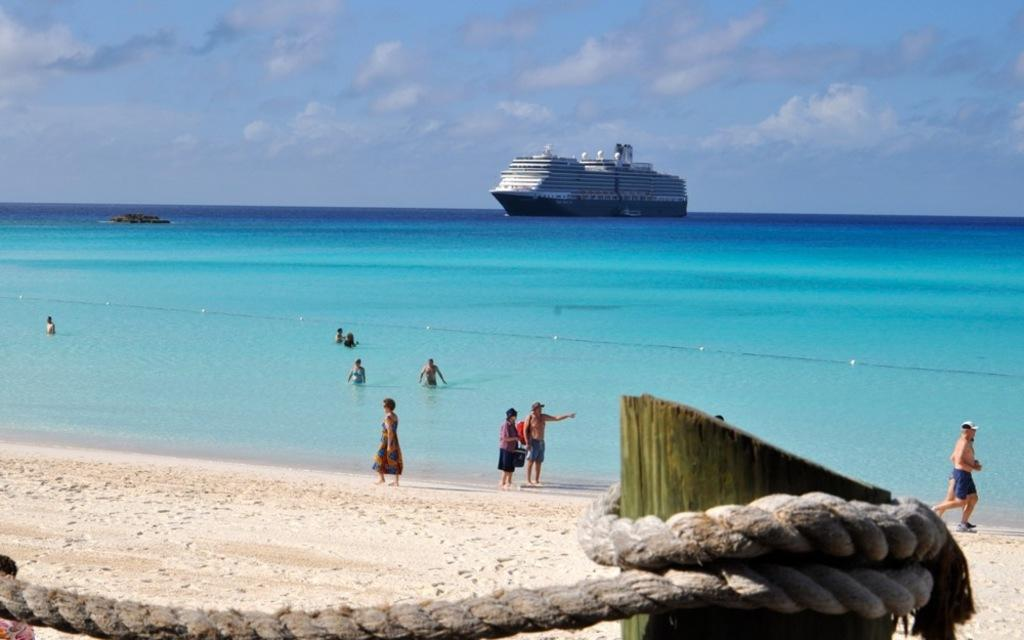What can be seen in the sky in the image? The sky with clouds is visible in the image. What is located on the sea in the image? There is a ship on the sea in the image. What are the people in the water doing? There are persons in the water, but their activities cannot be determined from the image. Where are the other persons located in the image? There are persons on the sea shore in the image. What object is tied with a rope in the image? A log is tied with a rope in the image. What type of society is being advertised in the image? There is no advertisement or society present in the image; it features a ship, people, and a log tied with a rope. 